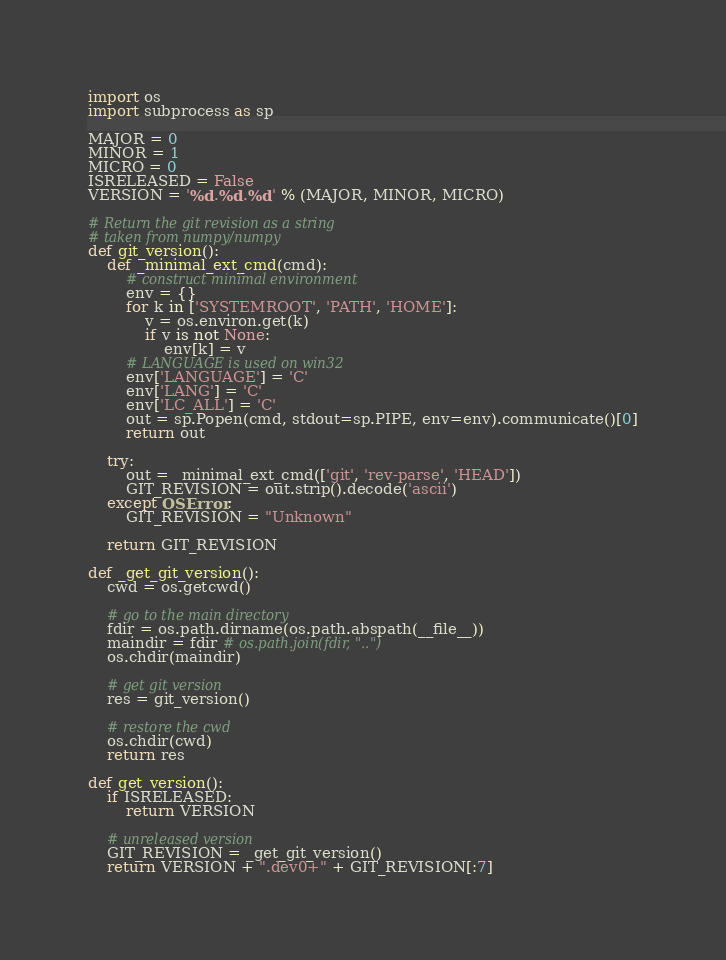<code> <loc_0><loc_0><loc_500><loc_500><_Python_>import os
import subprocess as sp

MAJOR = 0
MINOR = 1
MICRO = 0
ISRELEASED = False
VERSION = '%d.%d.%d' % (MAJOR, MINOR, MICRO)

# Return the git revision as a string
# taken from numpy/numpy
def git_version():
    def _minimal_ext_cmd(cmd):
        # construct minimal environment
        env = {}
        for k in ['SYSTEMROOT', 'PATH', 'HOME']:
            v = os.environ.get(k)
            if v is not None:
                env[k] = v
        # LANGUAGE is used on win32
        env['LANGUAGE'] = 'C'
        env['LANG'] = 'C'
        env['LC_ALL'] = 'C'
        out = sp.Popen(cmd, stdout=sp.PIPE, env=env).communicate()[0]
        return out

    try:
        out = _minimal_ext_cmd(['git', 'rev-parse', 'HEAD'])
        GIT_REVISION = out.strip().decode('ascii')
    except OSError:
        GIT_REVISION = "Unknown"

    return GIT_REVISION

def _get_git_version():
    cwd = os.getcwd()

    # go to the main directory
    fdir = os.path.dirname(os.path.abspath(__file__))
    maindir = fdir # os.path.join(fdir, "..")
    os.chdir(maindir)

    # get git version
    res = git_version()

    # restore the cwd
    os.chdir(cwd)
    return res

def get_version():
    if ISRELEASED:
        return VERSION

    # unreleased version
    GIT_REVISION = _get_git_version()
    return VERSION + ".dev0+" + GIT_REVISION[:7]
</code> 